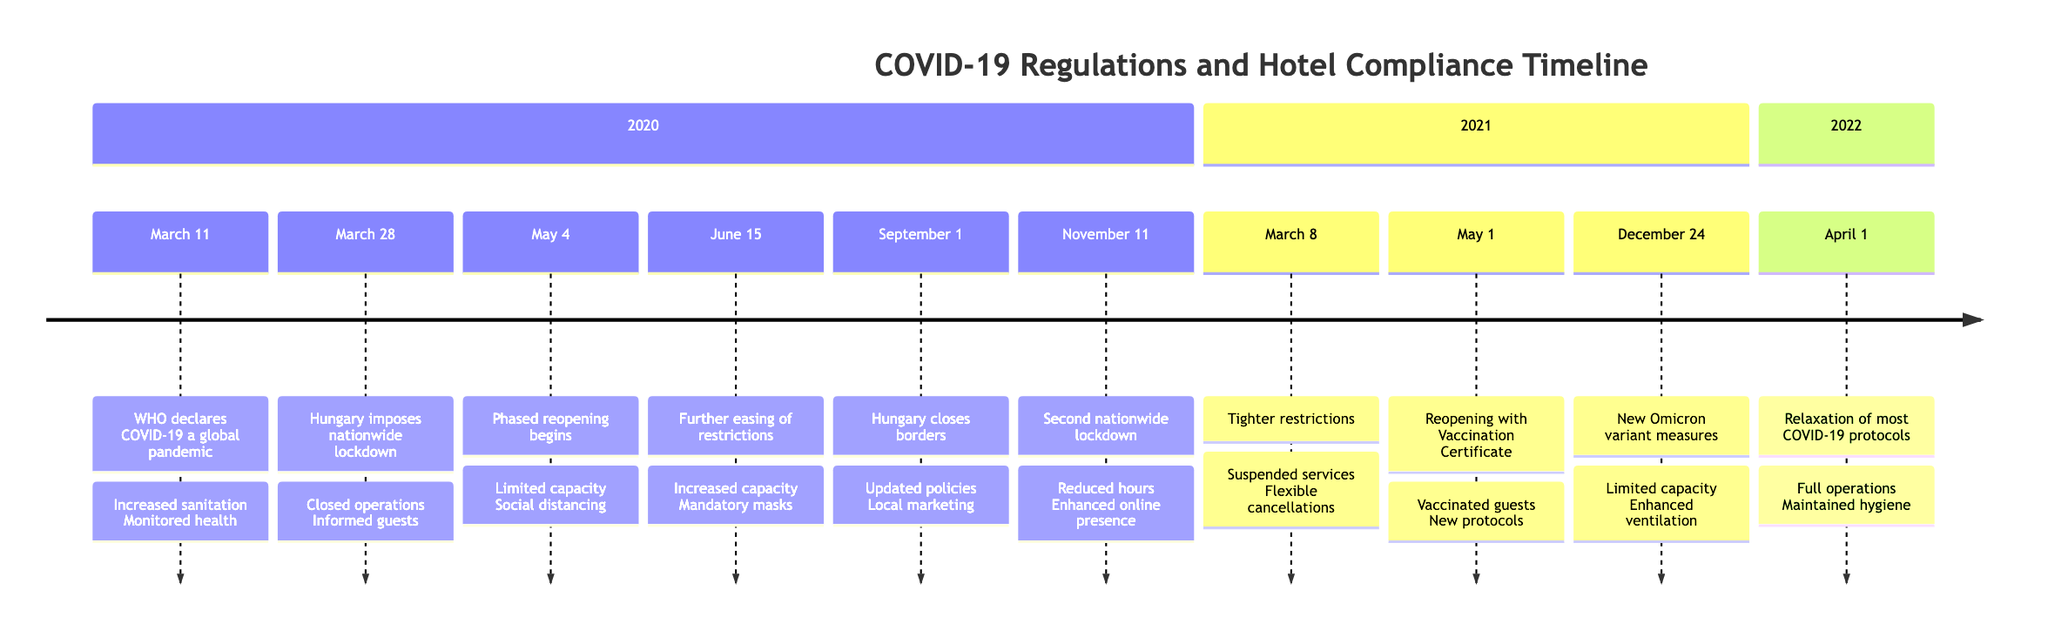What significant event occurred on March 11, 2020? The timeline indicates that on March 11, 2020, the World Health Organization declared COVID-19 a global pandemic, which set the stage for subsequent regulations.
Answer: WHO declares COVID-19 a global pandemic What actions were taken on March 28, 2020, following the nationwide lockdown? According to the timeline, after Hungary imposed a nationwide lockdown on March 28, 2020, the hotel closed operations and informed guests about cancellations and refund policies.
Answer: Closed hotel operations; Informed guests How long did the nationwide lockdown last before reopening on May 4, 2020? The lockdown began on March 28, 2020, and the hotel operations resumed on May 4, 2020. Calculating the duration gives us 37 days.
Answer: 37 days What protocols were implemented when the hotel reopened on May 4, 2020? The timeline shows that the hotel opened with limited capacity, implemented social distancing measures, and set up hand sanitizing stations upon reopening.
Answer: Limited capacity; Social distancing; Hand sanitizing stations When did Hungary close its borders to most foreigners? The timeline states that Hungary closed its borders to most foreigners on September 1, 2020.
Answer: September 1, 2020 What action was taken following the second nationwide lockdown on November 11, 2020? Public records indicate that after the second nationwide lockdown was imposed, the hotel reduced operational hours, enhanced its online presence for future bookings, and strengthened digital marketing strategies.
Answer: Reduced operational hours; Enhanced online presence What changes occurred after the reopening with a vaccination certificate on May 1, 2021? The timeline indicates that guests were allowed entry if vaccinated, the staff was trained on new health protocols, and contactless check-in systems were installed after this date.
Answer: Allowed entry for vaccinated guests; Trained staff; Installed contactless check-in systems What was the date of the relaxation of most COVID-19 protocols? According to the timeline, the relaxation of most COVID-19 protocols occurred on April 1, 2022.
Answer: April 1, 2022 What was a consistent sanitation measure maintained after the full operations resumed in April 2022? The timeline specifies that even after resuming full operations, certain hygiene practices were maintained as a standard, indicating a long-term commitment to health protocols.
Answer: Maintained some hygiene practices as a standard 